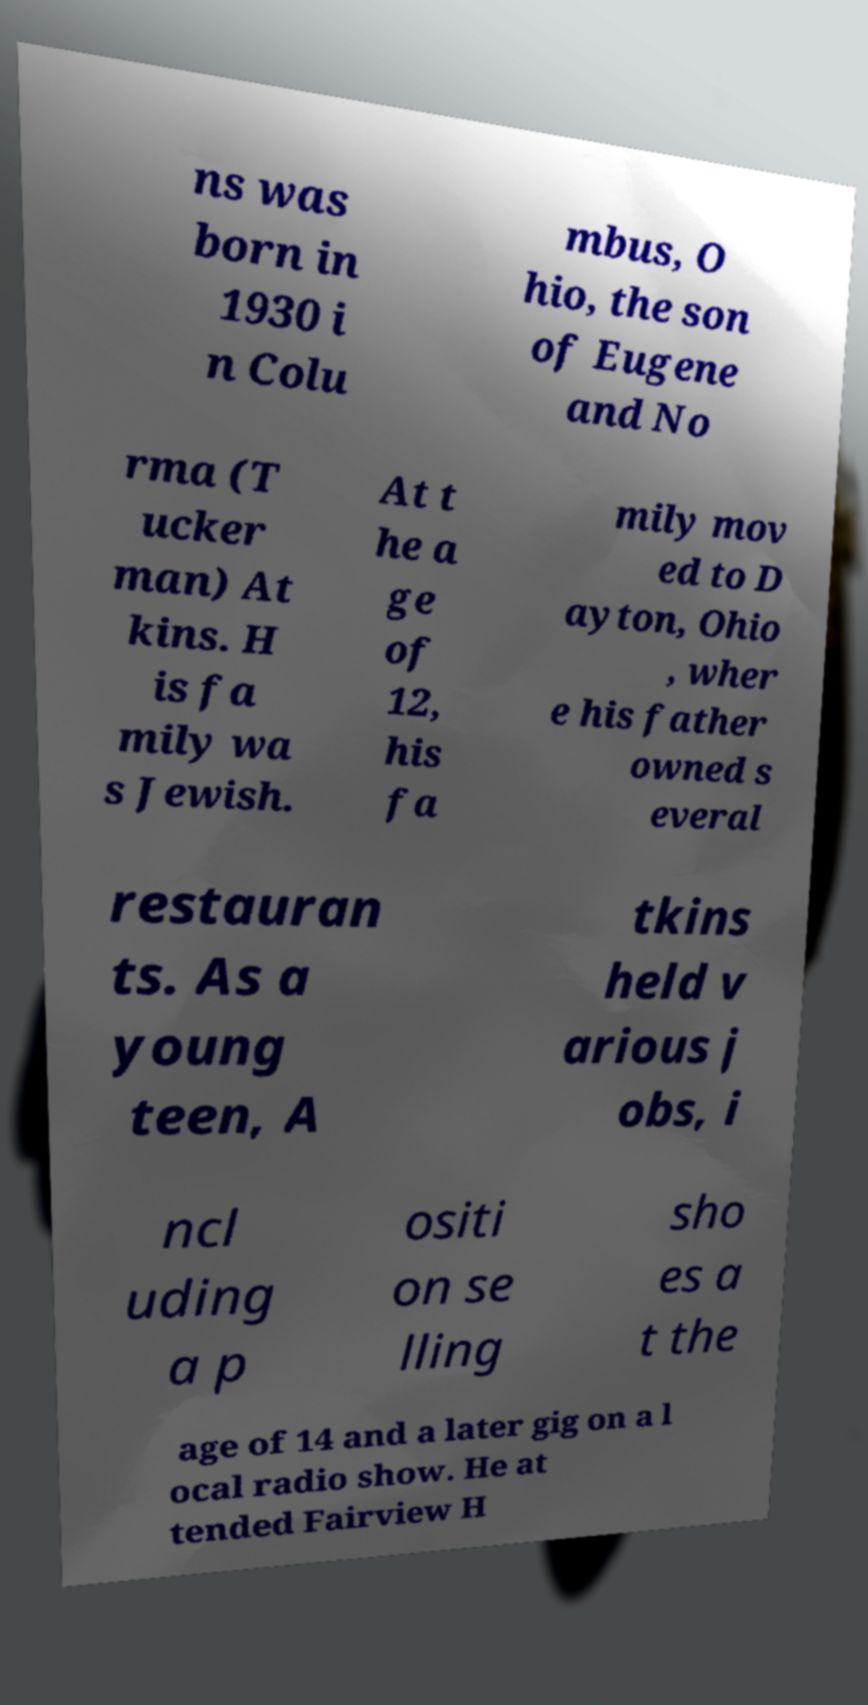Please identify and transcribe the text found in this image. ns was born in 1930 i n Colu mbus, O hio, the son of Eugene and No rma (T ucker man) At kins. H is fa mily wa s Jewish. At t he a ge of 12, his fa mily mov ed to D ayton, Ohio , wher e his father owned s everal restauran ts. As a young teen, A tkins held v arious j obs, i ncl uding a p ositi on se lling sho es a t the age of 14 and a later gig on a l ocal radio show. He at tended Fairview H 